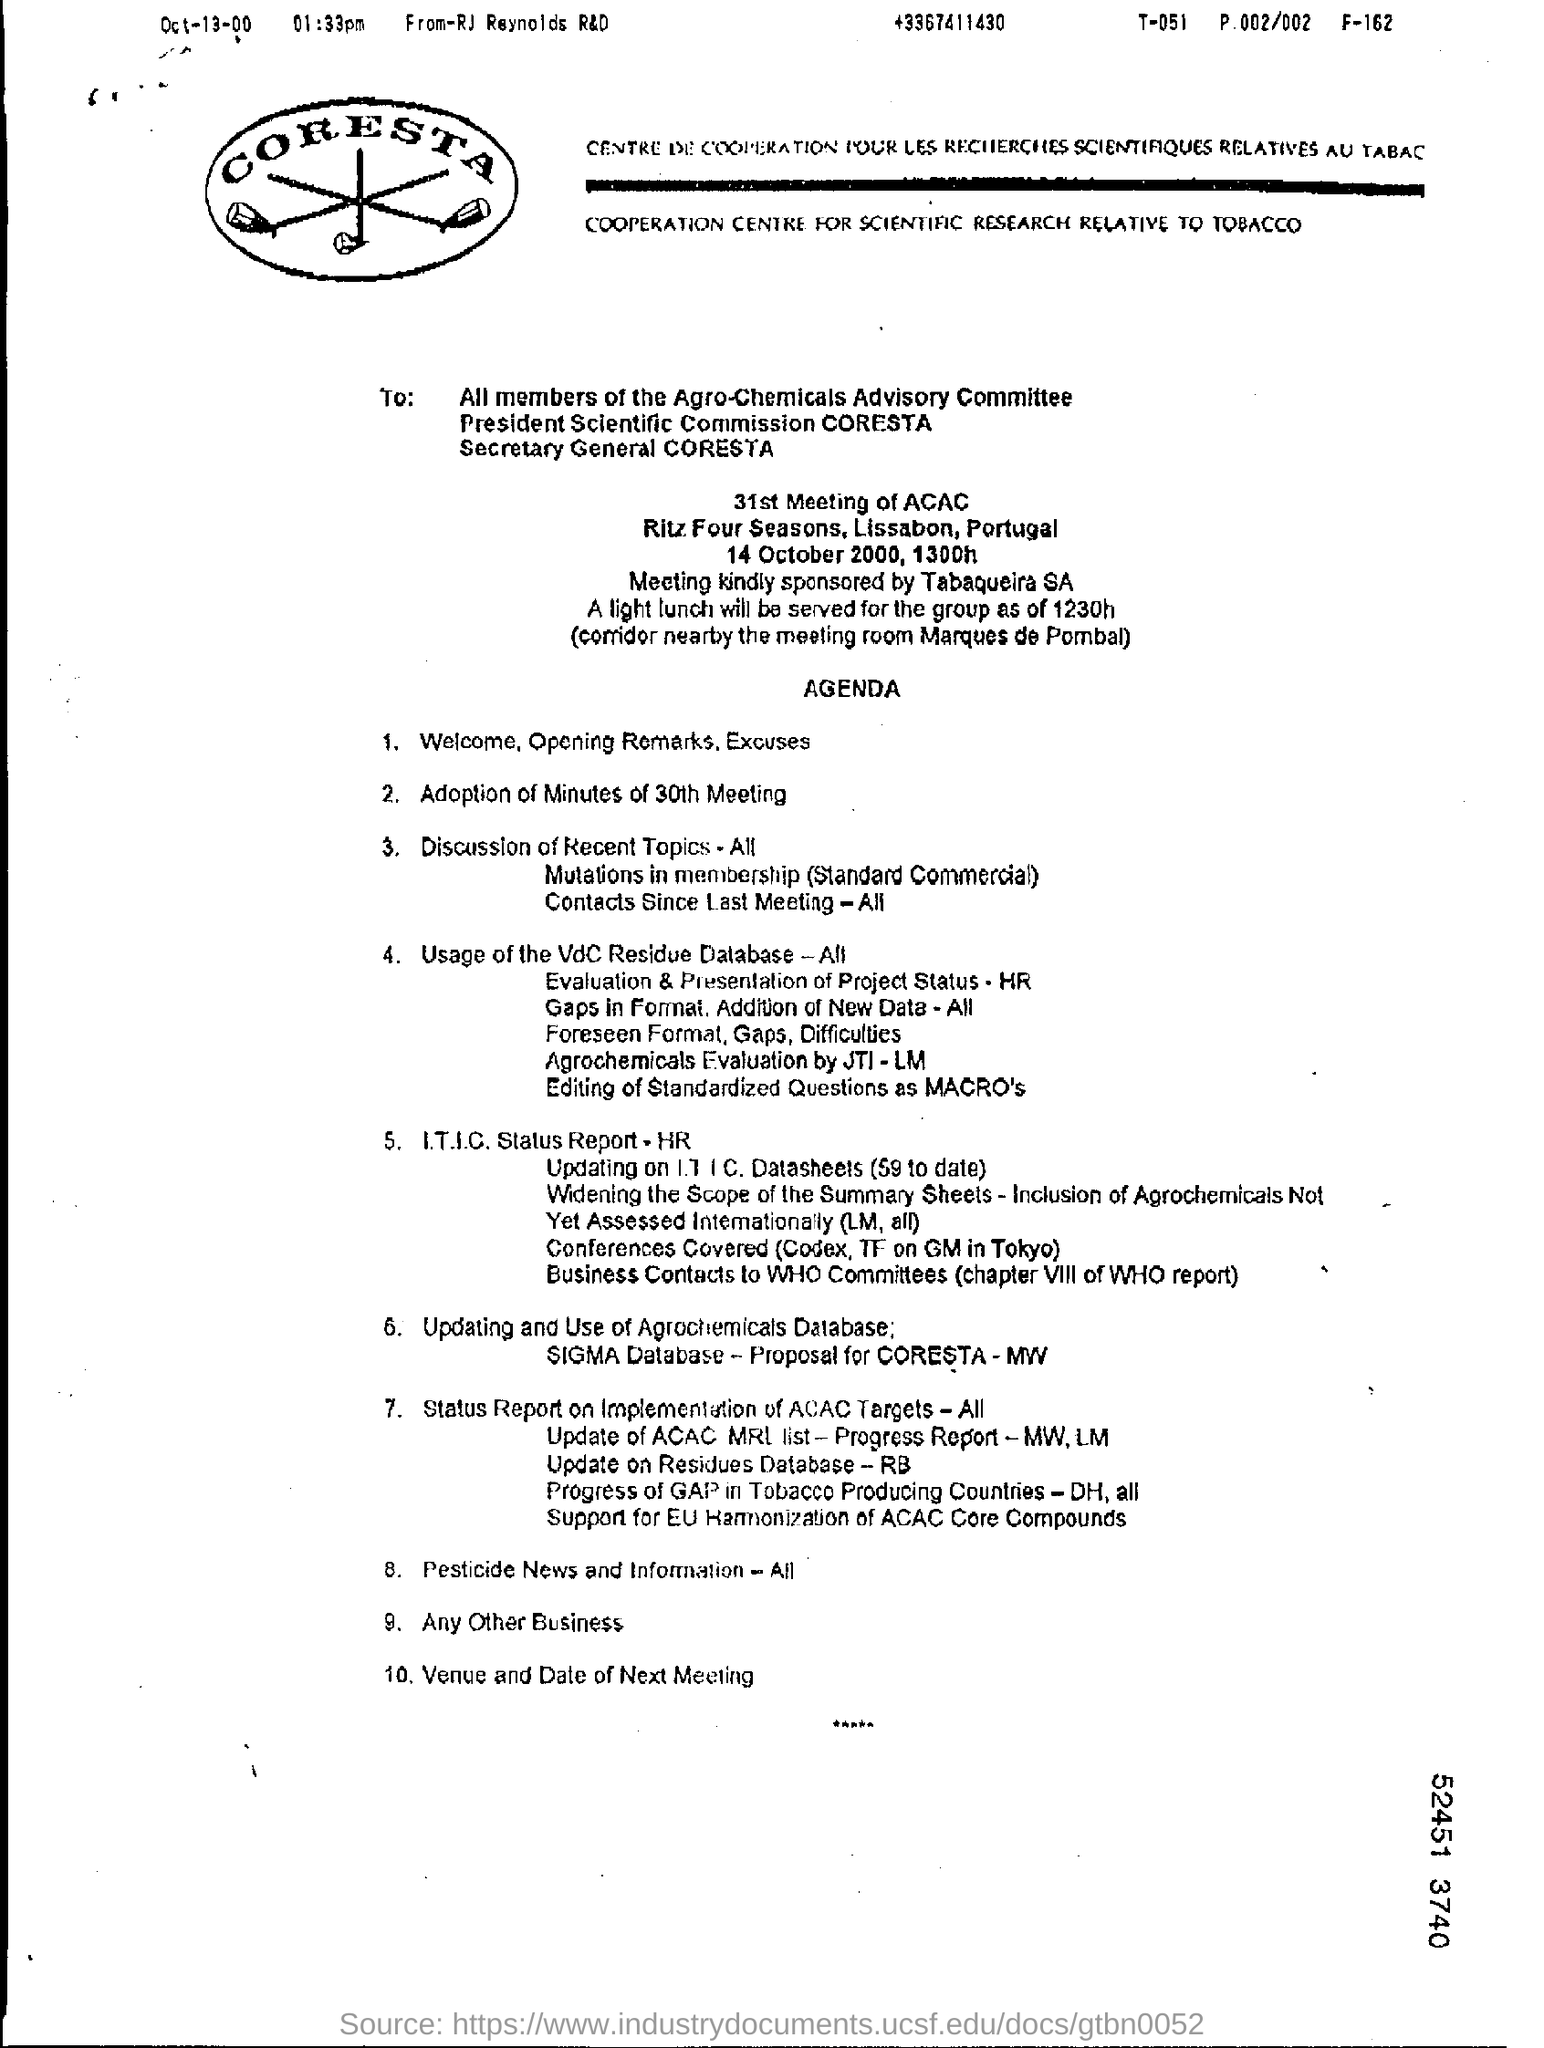Highlight a few significant elements in this photo. On the left top corner of the page, the date "Oct-13-00" was written. The agenda points are for the 31st meeting of the ACAC committee. The meeting will take place on October 14, 2000. The meeting is scheduled to begin at 1300 hours. RJ Reynolds R&D has written this document. 